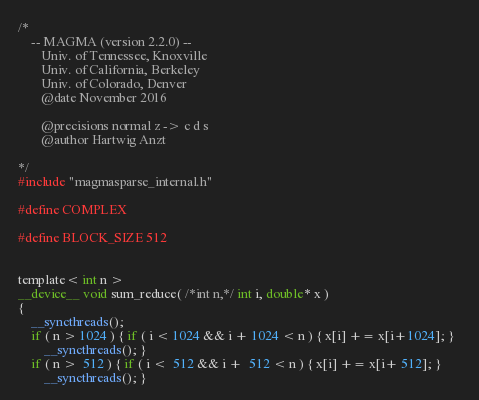<code> <loc_0><loc_0><loc_500><loc_500><_Cuda_>/*
    -- MAGMA (version 2.2.0) --
       Univ. of Tennessee, Knoxville
       Univ. of California, Berkeley
       Univ. of Colorado, Denver
       @date November 2016

       @precisions normal z -> c d s
       @author Hartwig Anzt

*/
#include "magmasparse_internal.h"

#define COMPLEX

#define BLOCK_SIZE 512


template< int n >
__device__ void sum_reduce( /*int n,*/ int i, double* x )
{
    __syncthreads();
    if ( n > 1024 ) { if ( i < 1024 && i + 1024 < n ) { x[i] += x[i+1024]; }  
        __syncthreads(); }
    if ( n >  512 ) { if ( i <  512 && i +  512 < n ) { x[i] += x[i+ 512]; }  
        __syncthreads(); }</code> 